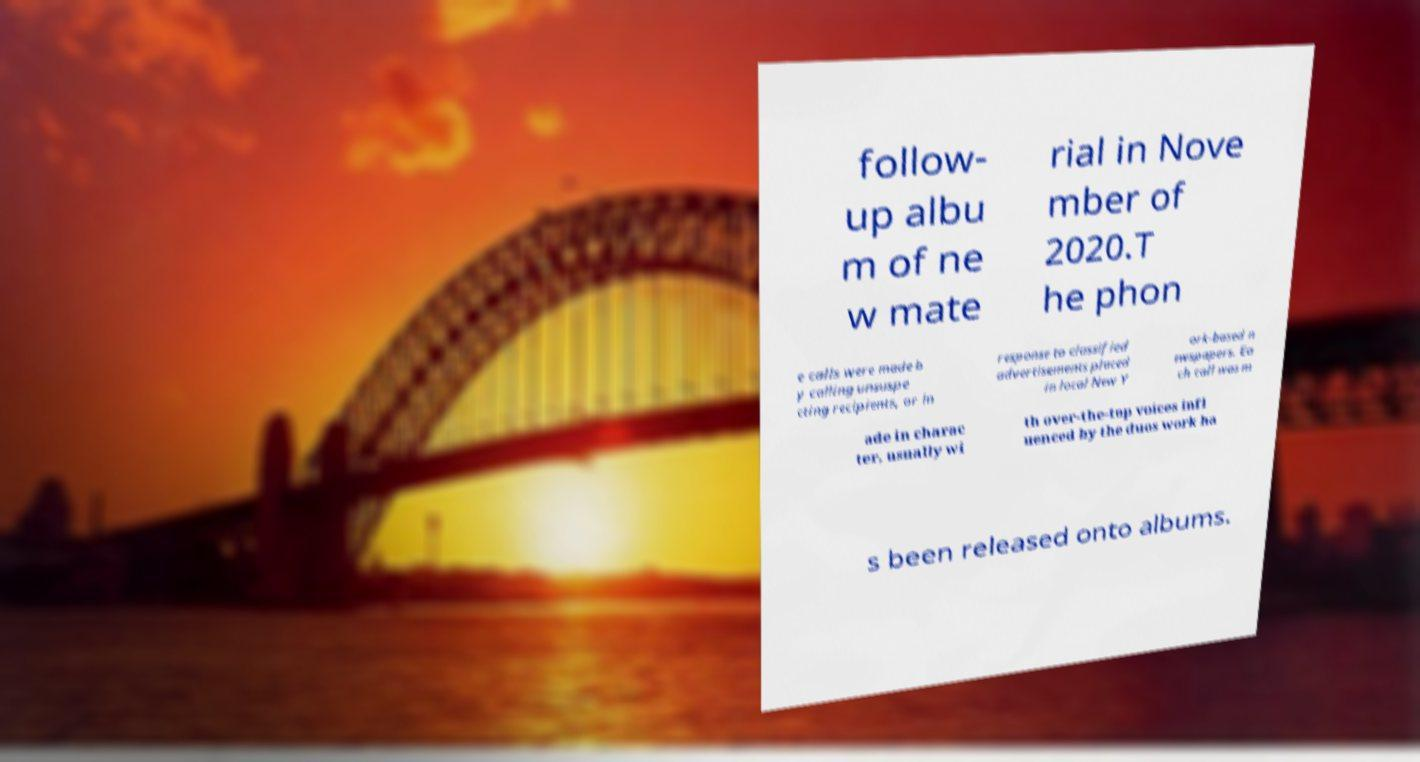For documentation purposes, I need the text within this image transcribed. Could you provide that? follow- up albu m of ne w mate rial in Nove mber of 2020.T he phon e calls were made b y calling unsuspe cting recipients, or in response to classified advertisements placed in local New Y ork-based n ewspapers. Ea ch call was m ade in charac ter, usually wi th over-the-top voices infl uenced by the duos work ha s been released onto albums. 